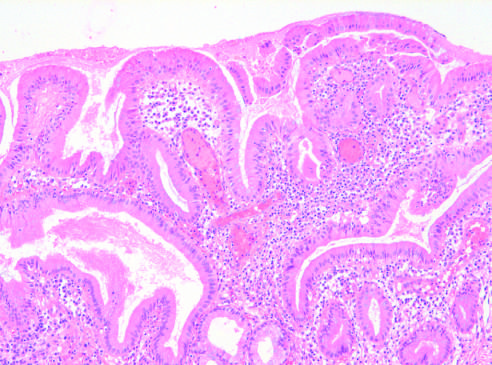s the gallbladder mucosa infiltrated by chronic inflammatory cells?
Answer the question using a single word or phrase. Yes 